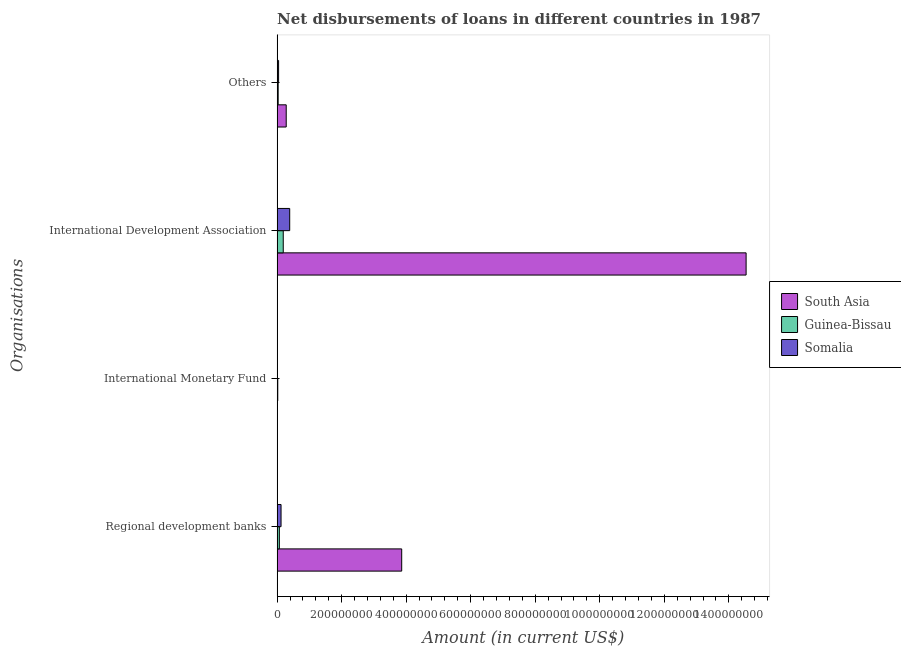How many different coloured bars are there?
Provide a succinct answer. 3. Are the number of bars per tick equal to the number of legend labels?
Your answer should be compact. No. How many bars are there on the 1st tick from the top?
Make the answer very short. 3. What is the label of the 3rd group of bars from the top?
Keep it short and to the point. International Monetary Fund. What is the amount of loan disimbursed by regional development banks in Somalia?
Provide a short and direct response. 1.22e+07. Across all countries, what is the maximum amount of loan disimbursed by regional development banks?
Your response must be concise. 3.86e+08. Across all countries, what is the minimum amount of loan disimbursed by regional development banks?
Ensure brevity in your answer.  6.93e+06. In which country was the amount of loan disimbursed by other organisations maximum?
Offer a very short reply. South Asia. What is the total amount of loan disimbursed by international development association in the graph?
Make the answer very short. 1.51e+09. What is the difference between the amount of loan disimbursed by regional development banks in Guinea-Bissau and that in Somalia?
Provide a short and direct response. -5.24e+06. What is the difference between the amount of loan disimbursed by other organisations in Guinea-Bissau and the amount of loan disimbursed by international monetary fund in Somalia?
Make the answer very short. 3.25e+06. What is the average amount of loan disimbursed by international development association per country?
Ensure brevity in your answer.  5.04e+08. What is the difference between the amount of loan disimbursed by other organisations and amount of loan disimbursed by regional development banks in Somalia?
Provide a succinct answer. -7.62e+06. What is the ratio of the amount of loan disimbursed by international development association in South Asia to that in Somalia?
Make the answer very short. 37.28. Is the amount of loan disimbursed by international development association in South Asia less than that in Guinea-Bissau?
Your response must be concise. No. What is the difference between the highest and the second highest amount of loan disimbursed by regional development banks?
Make the answer very short. 3.74e+08. What is the difference between the highest and the lowest amount of loan disimbursed by other organisations?
Provide a succinct answer. 2.49e+07. In how many countries, is the amount of loan disimbursed by other organisations greater than the average amount of loan disimbursed by other organisations taken over all countries?
Your answer should be very brief. 1. Is the sum of the amount of loan disimbursed by international development association in Somalia and South Asia greater than the maximum amount of loan disimbursed by international monetary fund across all countries?
Your answer should be compact. Yes. Are all the bars in the graph horizontal?
Offer a terse response. Yes. How many countries are there in the graph?
Give a very brief answer. 3. Does the graph contain grids?
Provide a succinct answer. No. What is the title of the graph?
Offer a very short reply. Net disbursements of loans in different countries in 1987. What is the label or title of the Y-axis?
Provide a succinct answer. Organisations. What is the Amount (in current US$) of South Asia in Regional development banks?
Offer a very short reply. 3.86e+08. What is the Amount (in current US$) in Guinea-Bissau in Regional development banks?
Your response must be concise. 6.93e+06. What is the Amount (in current US$) in Somalia in Regional development banks?
Provide a short and direct response. 1.22e+07. What is the Amount (in current US$) of Guinea-Bissau in International Monetary Fund?
Your answer should be compact. 1.96e+06. What is the Amount (in current US$) in Somalia in International Monetary Fund?
Offer a very short reply. 0. What is the Amount (in current US$) in South Asia in International Development Association?
Provide a succinct answer. 1.45e+09. What is the Amount (in current US$) of Guinea-Bissau in International Development Association?
Your response must be concise. 1.90e+07. What is the Amount (in current US$) of Somalia in International Development Association?
Your answer should be compact. 3.90e+07. What is the Amount (in current US$) of South Asia in Others?
Give a very brief answer. 2.82e+07. What is the Amount (in current US$) in Guinea-Bissau in Others?
Offer a very short reply. 3.25e+06. What is the Amount (in current US$) in Somalia in Others?
Offer a very short reply. 4.55e+06. Across all Organisations, what is the maximum Amount (in current US$) in South Asia?
Keep it short and to the point. 1.45e+09. Across all Organisations, what is the maximum Amount (in current US$) in Guinea-Bissau?
Keep it short and to the point. 1.90e+07. Across all Organisations, what is the maximum Amount (in current US$) in Somalia?
Your answer should be compact. 3.90e+07. Across all Organisations, what is the minimum Amount (in current US$) in Guinea-Bissau?
Your answer should be compact. 1.96e+06. Across all Organisations, what is the minimum Amount (in current US$) of Somalia?
Ensure brevity in your answer.  0. What is the total Amount (in current US$) in South Asia in the graph?
Your answer should be compact. 1.87e+09. What is the total Amount (in current US$) of Guinea-Bissau in the graph?
Keep it short and to the point. 3.11e+07. What is the total Amount (in current US$) of Somalia in the graph?
Provide a short and direct response. 5.57e+07. What is the difference between the Amount (in current US$) of Guinea-Bissau in Regional development banks and that in International Monetary Fund?
Give a very brief answer. 4.96e+06. What is the difference between the Amount (in current US$) in South Asia in Regional development banks and that in International Development Association?
Offer a terse response. -1.07e+09. What is the difference between the Amount (in current US$) in Guinea-Bissau in Regional development banks and that in International Development Association?
Provide a short and direct response. -1.20e+07. What is the difference between the Amount (in current US$) in Somalia in Regional development banks and that in International Development Association?
Offer a terse response. -2.68e+07. What is the difference between the Amount (in current US$) in South Asia in Regional development banks and that in Others?
Offer a terse response. 3.58e+08. What is the difference between the Amount (in current US$) in Guinea-Bissau in Regional development banks and that in Others?
Offer a very short reply. 3.68e+06. What is the difference between the Amount (in current US$) in Somalia in Regional development banks and that in Others?
Make the answer very short. 7.62e+06. What is the difference between the Amount (in current US$) in Guinea-Bissau in International Monetary Fund and that in International Development Association?
Provide a short and direct response. -1.70e+07. What is the difference between the Amount (in current US$) of Guinea-Bissau in International Monetary Fund and that in Others?
Provide a short and direct response. -1.28e+06. What is the difference between the Amount (in current US$) of South Asia in International Development Association and that in Others?
Ensure brevity in your answer.  1.43e+09. What is the difference between the Amount (in current US$) in Guinea-Bissau in International Development Association and that in Others?
Offer a very short reply. 1.57e+07. What is the difference between the Amount (in current US$) of Somalia in International Development Association and that in Others?
Make the answer very short. 3.44e+07. What is the difference between the Amount (in current US$) of South Asia in Regional development banks and the Amount (in current US$) of Guinea-Bissau in International Monetary Fund?
Your answer should be compact. 3.84e+08. What is the difference between the Amount (in current US$) of South Asia in Regional development banks and the Amount (in current US$) of Guinea-Bissau in International Development Association?
Provide a short and direct response. 3.67e+08. What is the difference between the Amount (in current US$) in South Asia in Regional development banks and the Amount (in current US$) in Somalia in International Development Association?
Give a very brief answer. 3.47e+08. What is the difference between the Amount (in current US$) in Guinea-Bissau in Regional development banks and the Amount (in current US$) in Somalia in International Development Association?
Your answer should be compact. -3.21e+07. What is the difference between the Amount (in current US$) in South Asia in Regional development banks and the Amount (in current US$) in Guinea-Bissau in Others?
Provide a short and direct response. 3.83e+08. What is the difference between the Amount (in current US$) in South Asia in Regional development banks and the Amount (in current US$) in Somalia in Others?
Keep it short and to the point. 3.82e+08. What is the difference between the Amount (in current US$) in Guinea-Bissau in Regional development banks and the Amount (in current US$) in Somalia in Others?
Your answer should be very brief. 2.38e+06. What is the difference between the Amount (in current US$) of Guinea-Bissau in International Monetary Fund and the Amount (in current US$) of Somalia in International Development Association?
Give a very brief answer. -3.70e+07. What is the difference between the Amount (in current US$) of Guinea-Bissau in International Monetary Fund and the Amount (in current US$) of Somalia in Others?
Your answer should be compact. -2.58e+06. What is the difference between the Amount (in current US$) of South Asia in International Development Association and the Amount (in current US$) of Guinea-Bissau in Others?
Make the answer very short. 1.45e+09. What is the difference between the Amount (in current US$) in South Asia in International Development Association and the Amount (in current US$) in Somalia in Others?
Your answer should be very brief. 1.45e+09. What is the difference between the Amount (in current US$) in Guinea-Bissau in International Development Association and the Amount (in current US$) in Somalia in Others?
Provide a succinct answer. 1.44e+07. What is the average Amount (in current US$) of South Asia per Organisations?
Your answer should be very brief. 4.67e+08. What is the average Amount (in current US$) of Guinea-Bissau per Organisations?
Your answer should be compact. 7.78e+06. What is the average Amount (in current US$) in Somalia per Organisations?
Provide a succinct answer. 1.39e+07. What is the difference between the Amount (in current US$) in South Asia and Amount (in current US$) in Guinea-Bissau in Regional development banks?
Make the answer very short. 3.79e+08. What is the difference between the Amount (in current US$) of South Asia and Amount (in current US$) of Somalia in Regional development banks?
Offer a terse response. 3.74e+08. What is the difference between the Amount (in current US$) in Guinea-Bissau and Amount (in current US$) in Somalia in Regional development banks?
Your answer should be compact. -5.24e+06. What is the difference between the Amount (in current US$) in South Asia and Amount (in current US$) in Guinea-Bissau in International Development Association?
Offer a terse response. 1.43e+09. What is the difference between the Amount (in current US$) of South Asia and Amount (in current US$) of Somalia in International Development Association?
Keep it short and to the point. 1.41e+09. What is the difference between the Amount (in current US$) of Guinea-Bissau and Amount (in current US$) of Somalia in International Development Association?
Provide a short and direct response. -2.00e+07. What is the difference between the Amount (in current US$) of South Asia and Amount (in current US$) of Guinea-Bissau in Others?
Offer a very short reply. 2.49e+07. What is the difference between the Amount (in current US$) in South Asia and Amount (in current US$) in Somalia in Others?
Your answer should be very brief. 2.36e+07. What is the difference between the Amount (in current US$) in Guinea-Bissau and Amount (in current US$) in Somalia in Others?
Your answer should be very brief. -1.30e+06. What is the ratio of the Amount (in current US$) of Guinea-Bissau in Regional development banks to that in International Monetary Fund?
Provide a succinct answer. 3.52. What is the ratio of the Amount (in current US$) of South Asia in Regional development banks to that in International Development Association?
Keep it short and to the point. 0.27. What is the ratio of the Amount (in current US$) in Guinea-Bissau in Regional development banks to that in International Development Association?
Make the answer very short. 0.37. What is the ratio of the Amount (in current US$) of Somalia in Regional development banks to that in International Development Association?
Offer a very short reply. 0.31. What is the ratio of the Amount (in current US$) in South Asia in Regional development banks to that in Others?
Make the answer very short. 13.71. What is the ratio of the Amount (in current US$) of Guinea-Bissau in Regional development banks to that in Others?
Provide a succinct answer. 2.13. What is the ratio of the Amount (in current US$) of Somalia in Regional development banks to that in Others?
Ensure brevity in your answer.  2.68. What is the ratio of the Amount (in current US$) of Guinea-Bissau in International Monetary Fund to that in International Development Association?
Give a very brief answer. 0.1. What is the ratio of the Amount (in current US$) of Guinea-Bissau in International Monetary Fund to that in Others?
Make the answer very short. 0.6. What is the ratio of the Amount (in current US$) of South Asia in International Development Association to that in Others?
Make the answer very short. 51.6. What is the ratio of the Amount (in current US$) of Guinea-Bissau in International Development Association to that in Others?
Provide a short and direct response. 5.84. What is the ratio of the Amount (in current US$) in Somalia in International Development Association to that in Others?
Your answer should be compact. 8.58. What is the difference between the highest and the second highest Amount (in current US$) in South Asia?
Your answer should be very brief. 1.07e+09. What is the difference between the highest and the second highest Amount (in current US$) of Guinea-Bissau?
Your response must be concise. 1.20e+07. What is the difference between the highest and the second highest Amount (in current US$) of Somalia?
Your answer should be compact. 2.68e+07. What is the difference between the highest and the lowest Amount (in current US$) in South Asia?
Offer a terse response. 1.45e+09. What is the difference between the highest and the lowest Amount (in current US$) in Guinea-Bissau?
Ensure brevity in your answer.  1.70e+07. What is the difference between the highest and the lowest Amount (in current US$) in Somalia?
Ensure brevity in your answer.  3.90e+07. 